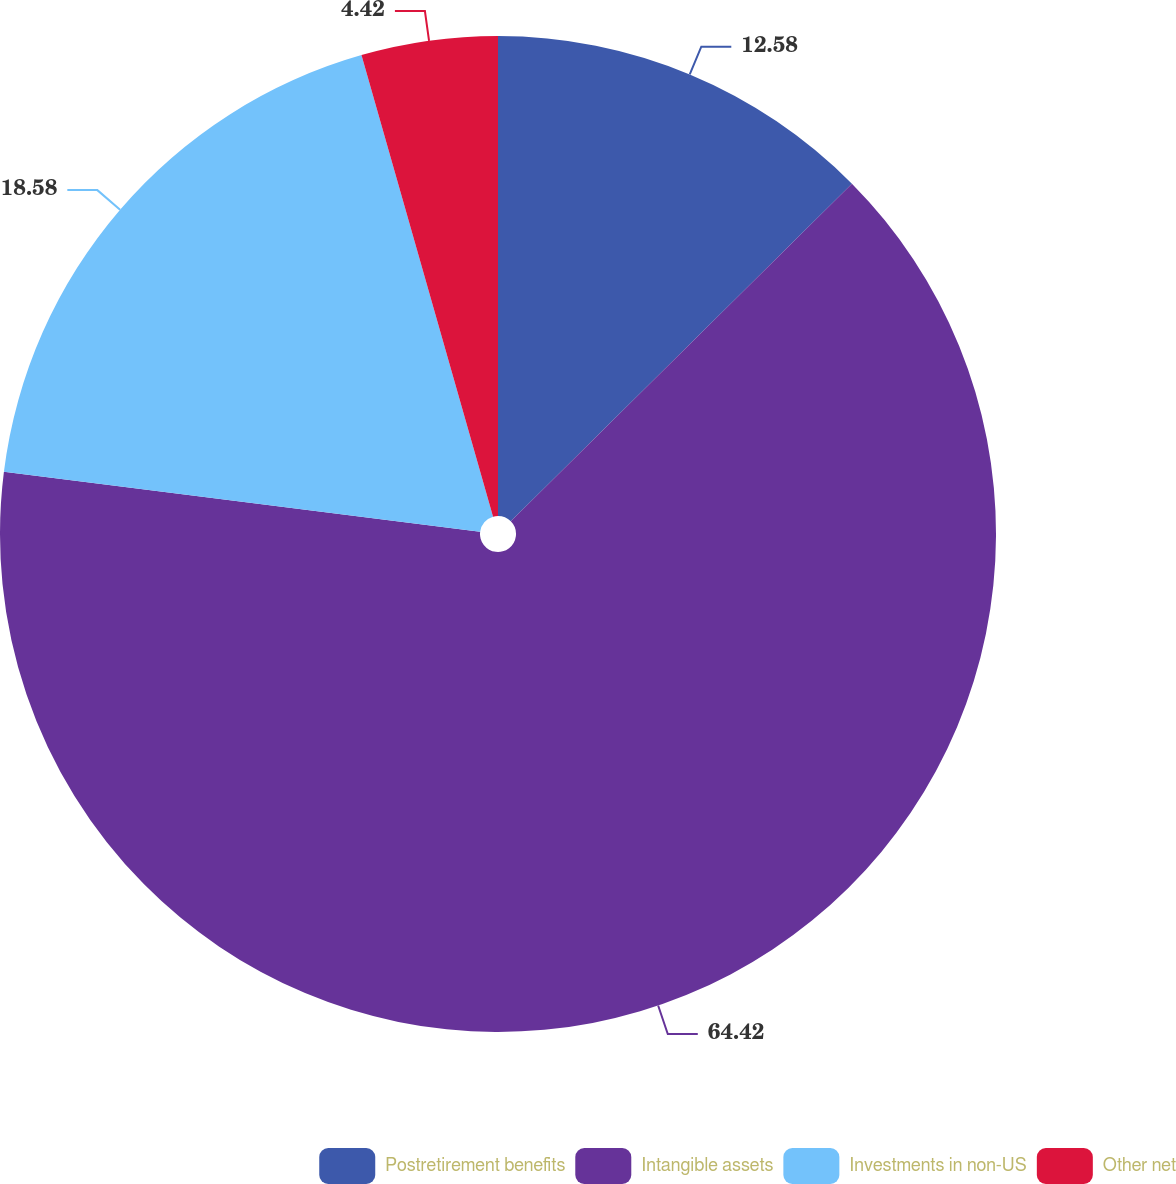Convert chart to OTSL. <chart><loc_0><loc_0><loc_500><loc_500><pie_chart><fcel>Postretirement benefits<fcel>Intangible assets<fcel>Investments in non-US<fcel>Other net<nl><fcel>12.58%<fcel>64.41%<fcel>18.58%<fcel>4.42%<nl></chart> 